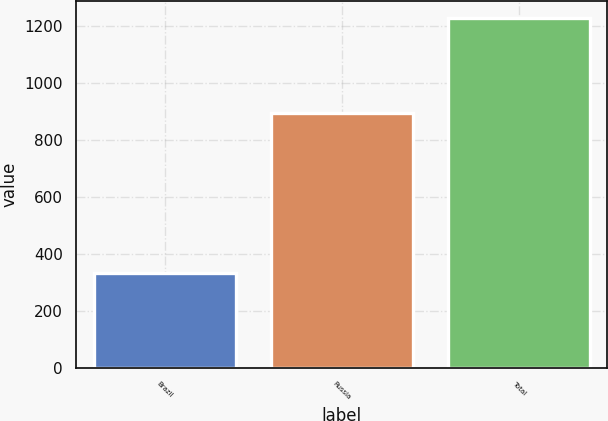Convert chart. <chart><loc_0><loc_0><loc_500><loc_500><bar_chart><fcel>Brazil<fcel>Russia<fcel>Total<nl><fcel>332<fcel>896<fcel>1228<nl></chart> 